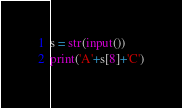Convert code to text. <code><loc_0><loc_0><loc_500><loc_500><_Python_>s = str(input())
print('A'+s[8]+'C')</code> 